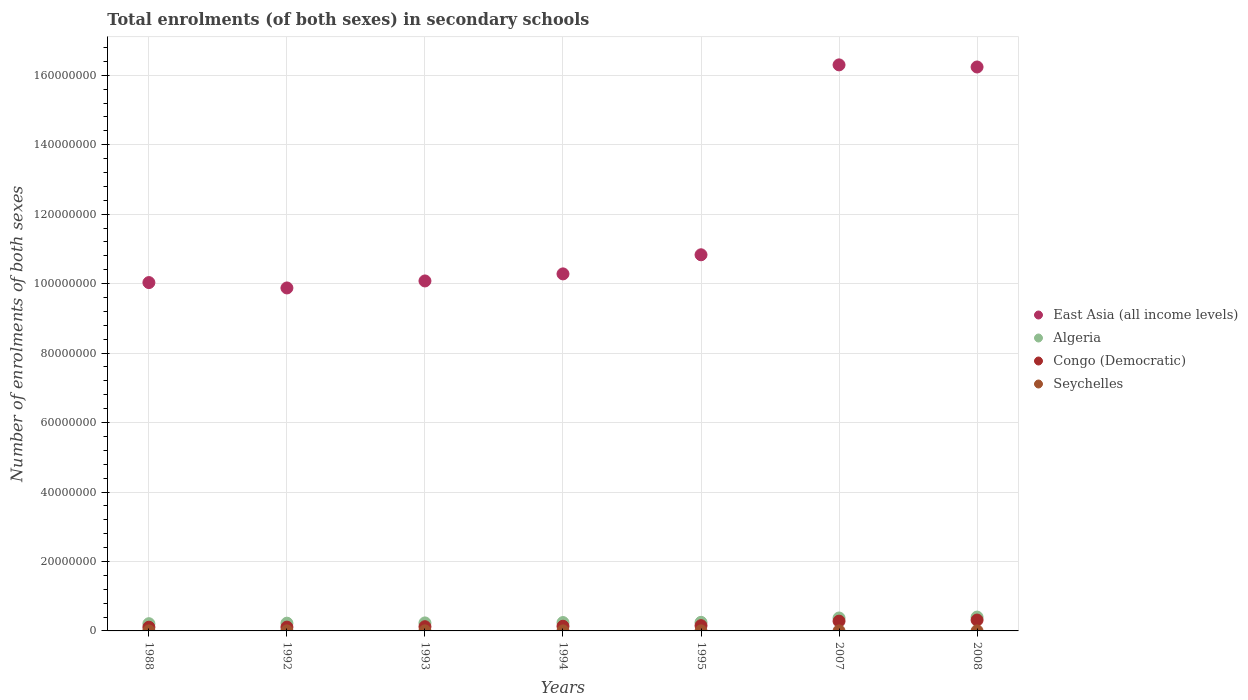How many different coloured dotlines are there?
Provide a succinct answer. 4. What is the number of enrolments in secondary schools in East Asia (all income levels) in 1995?
Your response must be concise. 1.08e+08. Across all years, what is the maximum number of enrolments in secondary schools in Congo (Democratic)?
Provide a succinct answer. 3.13e+06. Across all years, what is the minimum number of enrolments in secondary schools in Congo (Democratic)?
Your answer should be very brief. 1.07e+06. In which year was the number of enrolments in secondary schools in East Asia (all income levels) maximum?
Make the answer very short. 2007. What is the total number of enrolments in secondary schools in East Asia (all income levels) in the graph?
Your response must be concise. 8.36e+08. What is the difference between the number of enrolments in secondary schools in East Asia (all income levels) in 1994 and that in 2007?
Offer a very short reply. -6.02e+07. What is the difference between the number of enrolments in secondary schools in Algeria in 1993 and the number of enrolments in secondary schools in Congo (Democratic) in 2007?
Provide a short and direct response. -5.10e+05. What is the average number of enrolments in secondary schools in Seychelles per year?
Your answer should be compact. 8787.14. In the year 2008, what is the difference between the number of enrolments in secondary schools in Congo (Democratic) and number of enrolments in secondary schools in East Asia (all income levels)?
Provide a short and direct response. -1.59e+08. What is the ratio of the number of enrolments in secondary schools in Algeria in 1992 to that in 2007?
Your answer should be very brief. 0.6. Is the number of enrolments in secondary schools in East Asia (all income levels) in 1988 less than that in 2007?
Make the answer very short. Yes. What is the difference between the highest and the second highest number of enrolments in secondary schools in East Asia (all income levels)?
Give a very brief answer. 6.08e+05. What is the difference between the highest and the lowest number of enrolments in secondary schools in East Asia (all income levels)?
Your answer should be compact. 6.42e+07. In how many years, is the number of enrolments in secondary schools in Seychelles greater than the average number of enrolments in secondary schools in Seychelles taken over all years?
Provide a succinct answer. 5. Is the sum of the number of enrolments in secondary schools in Congo (Democratic) in 1994 and 2008 greater than the maximum number of enrolments in secondary schools in East Asia (all income levels) across all years?
Provide a short and direct response. No. Is it the case that in every year, the sum of the number of enrolments in secondary schools in East Asia (all income levels) and number of enrolments in secondary schools in Congo (Democratic)  is greater than the sum of number of enrolments in secondary schools in Seychelles and number of enrolments in secondary schools in Algeria?
Make the answer very short. No. How many years are there in the graph?
Offer a very short reply. 7. What is the difference between two consecutive major ticks on the Y-axis?
Offer a very short reply. 2.00e+07. Are the values on the major ticks of Y-axis written in scientific E-notation?
Provide a succinct answer. No. Does the graph contain any zero values?
Provide a short and direct response. No. How many legend labels are there?
Keep it short and to the point. 4. How are the legend labels stacked?
Give a very brief answer. Vertical. What is the title of the graph?
Offer a terse response. Total enrolments (of both sexes) in secondary schools. What is the label or title of the X-axis?
Ensure brevity in your answer.  Years. What is the label or title of the Y-axis?
Your response must be concise. Number of enrolments of both sexes. What is the Number of enrolments of both sexes of East Asia (all income levels) in 1988?
Keep it short and to the point. 1.00e+08. What is the Number of enrolments of both sexes of Algeria in 1988?
Your response must be concise. 2.08e+06. What is the Number of enrolments of both sexes in Congo (Democratic) in 1988?
Your response must be concise. 1.07e+06. What is the Number of enrolments of both sexes in Seychelles in 1988?
Your answer should be compact. 8868. What is the Number of enrolments of both sexes of East Asia (all income levels) in 1992?
Your answer should be compact. 9.88e+07. What is the Number of enrolments of both sexes in Algeria in 1992?
Provide a short and direct response. 2.23e+06. What is the Number of enrolments of both sexes in Congo (Democratic) in 1992?
Your answer should be compact. 1.10e+06. What is the Number of enrolments of both sexes in Seychelles in 1992?
Offer a very short reply. 9182. What is the Number of enrolments of both sexes in East Asia (all income levels) in 1993?
Make the answer very short. 1.01e+08. What is the Number of enrolments of both sexes of Algeria in 1993?
Offer a very short reply. 2.31e+06. What is the Number of enrolments of both sexes of Congo (Democratic) in 1993?
Provide a short and direct response. 1.22e+06. What is the Number of enrolments of both sexes in Seychelles in 1993?
Provide a succinct answer. 9111. What is the Number of enrolments of both sexes in East Asia (all income levels) in 1994?
Provide a succinct answer. 1.03e+08. What is the Number of enrolments of both sexes in Algeria in 1994?
Keep it short and to the point. 2.41e+06. What is the Number of enrolments of both sexes of Congo (Democratic) in 1994?
Give a very brief answer. 1.34e+06. What is the Number of enrolments of both sexes in Seychelles in 1994?
Offer a very short reply. 9280. What is the Number of enrolments of both sexes in East Asia (all income levels) in 1995?
Keep it short and to the point. 1.08e+08. What is the Number of enrolments of both sexes in Algeria in 1995?
Offer a very short reply. 2.47e+06. What is the Number of enrolments of both sexes of Congo (Democratic) in 1995?
Provide a succinct answer. 1.51e+06. What is the Number of enrolments of both sexes in Seychelles in 1995?
Your answer should be very brief. 8931. What is the Number of enrolments of both sexes of East Asia (all income levels) in 2007?
Your answer should be compact. 1.63e+08. What is the Number of enrolments of both sexes in Algeria in 2007?
Ensure brevity in your answer.  3.72e+06. What is the Number of enrolments of both sexes in Congo (Democratic) in 2007?
Your response must be concise. 2.82e+06. What is the Number of enrolments of both sexes in Seychelles in 2007?
Ensure brevity in your answer.  8227. What is the Number of enrolments of both sexes of East Asia (all income levels) in 2008?
Provide a short and direct response. 1.62e+08. What is the Number of enrolments of both sexes in Algeria in 2008?
Make the answer very short. 3.98e+06. What is the Number of enrolments of both sexes in Congo (Democratic) in 2008?
Give a very brief answer. 3.13e+06. What is the Number of enrolments of both sexes of Seychelles in 2008?
Give a very brief answer. 7911. Across all years, what is the maximum Number of enrolments of both sexes in East Asia (all income levels)?
Offer a terse response. 1.63e+08. Across all years, what is the maximum Number of enrolments of both sexes of Algeria?
Your answer should be very brief. 3.98e+06. Across all years, what is the maximum Number of enrolments of both sexes in Congo (Democratic)?
Your answer should be compact. 3.13e+06. Across all years, what is the maximum Number of enrolments of both sexes in Seychelles?
Offer a terse response. 9280. Across all years, what is the minimum Number of enrolments of both sexes in East Asia (all income levels)?
Offer a very short reply. 9.88e+07. Across all years, what is the minimum Number of enrolments of both sexes of Algeria?
Your response must be concise. 2.08e+06. Across all years, what is the minimum Number of enrolments of both sexes in Congo (Democratic)?
Give a very brief answer. 1.07e+06. Across all years, what is the minimum Number of enrolments of both sexes of Seychelles?
Provide a short and direct response. 7911. What is the total Number of enrolments of both sexes of East Asia (all income levels) in the graph?
Your answer should be very brief. 8.36e+08. What is the total Number of enrolments of both sexes in Algeria in the graph?
Your answer should be very brief. 1.92e+07. What is the total Number of enrolments of both sexes in Congo (Democratic) in the graph?
Make the answer very short. 1.22e+07. What is the total Number of enrolments of both sexes of Seychelles in the graph?
Offer a terse response. 6.15e+04. What is the difference between the Number of enrolments of both sexes of East Asia (all income levels) in 1988 and that in 1992?
Keep it short and to the point. 1.55e+06. What is the difference between the Number of enrolments of both sexes of Algeria in 1988 and that in 1992?
Provide a short and direct response. -1.50e+05. What is the difference between the Number of enrolments of both sexes in Congo (Democratic) in 1988 and that in 1992?
Provide a short and direct response. -3.07e+04. What is the difference between the Number of enrolments of both sexes of Seychelles in 1988 and that in 1992?
Offer a very short reply. -314. What is the difference between the Number of enrolments of both sexes of East Asia (all income levels) in 1988 and that in 1993?
Give a very brief answer. -4.70e+05. What is the difference between the Number of enrolments of both sexes in Algeria in 1988 and that in 1993?
Keep it short and to the point. -2.23e+05. What is the difference between the Number of enrolments of both sexes of Congo (Democratic) in 1988 and that in 1993?
Your response must be concise. -1.52e+05. What is the difference between the Number of enrolments of both sexes of Seychelles in 1988 and that in 1993?
Make the answer very short. -243. What is the difference between the Number of enrolments of both sexes of East Asia (all income levels) in 1988 and that in 1994?
Provide a succinct answer. -2.50e+06. What is the difference between the Number of enrolments of both sexes of Algeria in 1988 and that in 1994?
Provide a short and direct response. -3.29e+05. What is the difference between the Number of enrolments of both sexes of Congo (Democratic) in 1988 and that in 1994?
Provide a short and direct response. -2.75e+05. What is the difference between the Number of enrolments of both sexes in Seychelles in 1988 and that in 1994?
Offer a very short reply. -412. What is the difference between the Number of enrolments of both sexes in East Asia (all income levels) in 1988 and that in 1995?
Keep it short and to the point. -8.00e+06. What is the difference between the Number of enrolments of both sexes in Algeria in 1988 and that in 1995?
Ensure brevity in your answer.  -3.90e+05. What is the difference between the Number of enrolments of both sexes of Congo (Democratic) in 1988 and that in 1995?
Keep it short and to the point. -4.48e+05. What is the difference between the Number of enrolments of both sexes of Seychelles in 1988 and that in 1995?
Offer a terse response. -63. What is the difference between the Number of enrolments of both sexes in East Asia (all income levels) in 1988 and that in 2007?
Provide a succinct answer. -6.27e+07. What is the difference between the Number of enrolments of both sexes in Algeria in 1988 and that in 2007?
Provide a short and direct response. -1.64e+06. What is the difference between the Number of enrolments of both sexes in Congo (Democratic) in 1988 and that in 2007?
Make the answer very short. -1.75e+06. What is the difference between the Number of enrolments of both sexes of Seychelles in 1988 and that in 2007?
Your response must be concise. 641. What is the difference between the Number of enrolments of both sexes of East Asia (all income levels) in 1988 and that in 2008?
Your answer should be compact. -6.21e+07. What is the difference between the Number of enrolments of both sexes of Algeria in 1988 and that in 2008?
Make the answer very short. -1.90e+06. What is the difference between the Number of enrolments of both sexes in Congo (Democratic) in 1988 and that in 2008?
Your answer should be very brief. -2.06e+06. What is the difference between the Number of enrolments of both sexes of Seychelles in 1988 and that in 2008?
Provide a succinct answer. 957. What is the difference between the Number of enrolments of both sexes of East Asia (all income levels) in 1992 and that in 1993?
Your response must be concise. -2.02e+06. What is the difference between the Number of enrolments of both sexes in Algeria in 1992 and that in 1993?
Your answer should be compact. -7.24e+04. What is the difference between the Number of enrolments of both sexes of Congo (Democratic) in 1992 and that in 1993?
Your response must be concise. -1.22e+05. What is the difference between the Number of enrolments of both sexes of East Asia (all income levels) in 1992 and that in 1994?
Give a very brief answer. -4.05e+06. What is the difference between the Number of enrolments of both sexes of Algeria in 1992 and that in 1994?
Make the answer very short. -1.79e+05. What is the difference between the Number of enrolments of both sexes of Congo (Democratic) in 1992 and that in 1994?
Make the answer very short. -2.44e+05. What is the difference between the Number of enrolments of both sexes of Seychelles in 1992 and that in 1994?
Offer a terse response. -98. What is the difference between the Number of enrolments of both sexes in East Asia (all income levels) in 1992 and that in 1995?
Provide a succinct answer. -9.55e+06. What is the difference between the Number of enrolments of both sexes of Algeria in 1992 and that in 1995?
Make the answer very short. -2.40e+05. What is the difference between the Number of enrolments of both sexes of Congo (Democratic) in 1992 and that in 1995?
Give a very brief answer. -4.17e+05. What is the difference between the Number of enrolments of both sexes of Seychelles in 1992 and that in 1995?
Your answer should be compact. 251. What is the difference between the Number of enrolments of both sexes of East Asia (all income levels) in 1992 and that in 2007?
Your answer should be very brief. -6.42e+07. What is the difference between the Number of enrolments of both sexes in Algeria in 1992 and that in 2007?
Your response must be concise. -1.49e+06. What is the difference between the Number of enrolments of both sexes in Congo (Democratic) in 1992 and that in 2007?
Keep it short and to the point. -1.72e+06. What is the difference between the Number of enrolments of both sexes in Seychelles in 1992 and that in 2007?
Provide a short and direct response. 955. What is the difference between the Number of enrolments of both sexes of East Asia (all income levels) in 1992 and that in 2008?
Offer a very short reply. -6.36e+07. What is the difference between the Number of enrolments of both sexes in Algeria in 1992 and that in 2008?
Your response must be concise. -1.75e+06. What is the difference between the Number of enrolments of both sexes of Congo (Democratic) in 1992 and that in 2008?
Ensure brevity in your answer.  -2.03e+06. What is the difference between the Number of enrolments of both sexes of Seychelles in 1992 and that in 2008?
Keep it short and to the point. 1271. What is the difference between the Number of enrolments of both sexes in East Asia (all income levels) in 1993 and that in 1994?
Your response must be concise. -2.03e+06. What is the difference between the Number of enrolments of both sexes in Algeria in 1993 and that in 1994?
Offer a terse response. -1.07e+05. What is the difference between the Number of enrolments of both sexes of Congo (Democratic) in 1993 and that in 1994?
Your answer should be very brief. -1.23e+05. What is the difference between the Number of enrolments of both sexes of Seychelles in 1993 and that in 1994?
Make the answer very short. -169. What is the difference between the Number of enrolments of both sexes of East Asia (all income levels) in 1993 and that in 1995?
Your answer should be compact. -7.53e+06. What is the difference between the Number of enrolments of both sexes in Algeria in 1993 and that in 1995?
Your response must be concise. -1.67e+05. What is the difference between the Number of enrolments of both sexes in Congo (Democratic) in 1993 and that in 1995?
Your response must be concise. -2.96e+05. What is the difference between the Number of enrolments of both sexes in Seychelles in 1993 and that in 1995?
Your response must be concise. 180. What is the difference between the Number of enrolments of both sexes of East Asia (all income levels) in 1993 and that in 2007?
Offer a very short reply. -6.22e+07. What is the difference between the Number of enrolments of both sexes of Algeria in 1993 and that in 2007?
Make the answer very short. -1.42e+06. What is the difference between the Number of enrolments of both sexes in Congo (Democratic) in 1993 and that in 2007?
Keep it short and to the point. -1.60e+06. What is the difference between the Number of enrolments of both sexes in Seychelles in 1993 and that in 2007?
Your response must be concise. 884. What is the difference between the Number of enrolments of both sexes in East Asia (all income levels) in 1993 and that in 2008?
Your response must be concise. -6.16e+07. What is the difference between the Number of enrolments of both sexes of Algeria in 1993 and that in 2008?
Keep it short and to the point. -1.68e+06. What is the difference between the Number of enrolments of both sexes in Congo (Democratic) in 1993 and that in 2008?
Provide a succinct answer. -1.91e+06. What is the difference between the Number of enrolments of both sexes in Seychelles in 1993 and that in 2008?
Ensure brevity in your answer.  1200. What is the difference between the Number of enrolments of both sexes in East Asia (all income levels) in 1994 and that in 1995?
Provide a short and direct response. -5.50e+06. What is the difference between the Number of enrolments of both sexes of Algeria in 1994 and that in 1995?
Give a very brief answer. -6.05e+04. What is the difference between the Number of enrolments of both sexes of Congo (Democratic) in 1994 and that in 1995?
Your answer should be compact. -1.73e+05. What is the difference between the Number of enrolments of both sexes of Seychelles in 1994 and that in 1995?
Ensure brevity in your answer.  349. What is the difference between the Number of enrolments of both sexes of East Asia (all income levels) in 1994 and that in 2007?
Provide a short and direct response. -6.02e+07. What is the difference between the Number of enrolments of both sexes in Algeria in 1994 and that in 2007?
Make the answer very short. -1.31e+06. What is the difference between the Number of enrolments of both sexes of Congo (Democratic) in 1994 and that in 2007?
Your response must be concise. -1.47e+06. What is the difference between the Number of enrolments of both sexes in Seychelles in 1994 and that in 2007?
Your answer should be compact. 1053. What is the difference between the Number of enrolments of both sexes of East Asia (all income levels) in 1994 and that in 2008?
Your answer should be compact. -5.96e+07. What is the difference between the Number of enrolments of both sexes of Algeria in 1994 and that in 2008?
Your answer should be compact. -1.57e+06. What is the difference between the Number of enrolments of both sexes of Congo (Democratic) in 1994 and that in 2008?
Offer a very short reply. -1.79e+06. What is the difference between the Number of enrolments of both sexes of Seychelles in 1994 and that in 2008?
Your response must be concise. 1369. What is the difference between the Number of enrolments of both sexes in East Asia (all income levels) in 1995 and that in 2007?
Your answer should be compact. -5.47e+07. What is the difference between the Number of enrolments of both sexes of Algeria in 1995 and that in 2007?
Ensure brevity in your answer.  -1.25e+06. What is the difference between the Number of enrolments of both sexes in Congo (Democratic) in 1995 and that in 2007?
Ensure brevity in your answer.  -1.30e+06. What is the difference between the Number of enrolments of both sexes in Seychelles in 1995 and that in 2007?
Ensure brevity in your answer.  704. What is the difference between the Number of enrolments of both sexes in East Asia (all income levels) in 1995 and that in 2008?
Your answer should be compact. -5.41e+07. What is the difference between the Number of enrolments of both sexes in Algeria in 1995 and that in 2008?
Your answer should be very brief. -1.51e+06. What is the difference between the Number of enrolments of both sexes of Congo (Democratic) in 1995 and that in 2008?
Offer a very short reply. -1.62e+06. What is the difference between the Number of enrolments of both sexes in Seychelles in 1995 and that in 2008?
Your answer should be compact. 1020. What is the difference between the Number of enrolments of both sexes of East Asia (all income levels) in 2007 and that in 2008?
Offer a terse response. 6.08e+05. What is the difference between the Number of enrolments of both sexes in Algeria in 2007 and that in 2008?
Provide a short and direct response. -2.60e+05. What is the difference between the Number of enrolments of both sexes in Congo (Democratic) in 2007 and that in 2008?
Give a very brief answer. -3.14e+05. What is the difference between the Number of enrolments of both sexes in Seychelles in 2007 and that in 2008?
Offer a terse response. 316. What is the difference between the Number of enrolments of both sexes of East Asia (all income levels) in 1988 and the Number of enrolments of both sexes of Algeria in 1992?
Offer a terse response. 9.81e+07. What is the difference between the Number of enrolments of both sexes in East Asia (all income levels) in 1988 and the Number of enrolments of both sexes in Congo (Democratic) in 1992?
Give a very brief answer. 9.92e+07. What is the difference between the Number of enrolments of both sexes in East Asia (all income levels) in 1988 and the Number of enrolments of both sexes in Seychelles in 1992?
Ensure brevity in your answer.  1.00e+08. What is the difference between the Number of enrolments of both sexes in Algeria in 1988 and the Number of enrolments of both sexes in Congo (Democratic) in 1992?
Your answer should be compact. 9.86e+05. What is the difference between the Number of enrolments of both sexes of Algeria in 1988 and the Number of enrolments of both sexes of Seychelles in 1992?
Keep it short and to the point. 2.07e+06. What is the difference between the Number of enrolments of both sexes of Congo (Democratic) in 1988 and the Number of enrolments of both sexes of Seychelles in 1992?
Ensure brevity in your answer.  1.06e+06. What is the difference between the Number of enrolments of both sexes in East Asia (all income levels) in 1988 and the Number of enrolments of both sexes in Algeria in 1993?
Your answer should be very brief. 9.80e+07. What is the difference between the Number of enrolments of both sexes of East Asia (all income levels) in 1988 and the Number of enrolments of both sexes of Congo (Democratic) in 1993?
Your response must be concise. 9.91e+07. What is the difference between the Number of enrolments of both sexes in East Asia (all income levels) in 1988 and the Number of enrolments of both sexes in Seychelles in 1993?
Offer a very short reply. 1.00e+08. What is the difference between the Number of enrolments of both sexes in Algeria in 1988 and the Number of enrolments of both sexes in Congo (Democratic) in 1993?
Make the answer very short. 8.64e+05. What is the difference between the Number of enrolments of both sexes of Algeria in 1988 and the Number of enrolments of both sexes of Seychelles in 1993?
Keep it short and to the point. 2.07e+06. What is the difference between the Number of enrolments of both sexes of Congo (Democratic) in 1988 and the Number of enrolments of both sexes of Seychelles in 1993?
Your answer should be compact. 1.06e+06. What is the difference between the Number of enrolments of both sexes in East Asia (all income levels) in 1988 and the Number of enrolments of both sexes in Algeria in 1994?
Offer a terse response. 9.79e+07. What is the difference between the Number of enrolments of both sexes of East Asia (all income levels) in 1988 and the Number of enrolments of both sexes of Congo (Democratic) in 1994?
Provide a succinct answer. 9.90e+07. What is the difference between the Number of enrolments of both sexes of East Asia (all income levels) in 1988 and the Number of enrolments of both sexes of Seychelles in 1994?
Give a very brief answer. 1.00e+08. What is the difference between the Number of enrolments of both sexes of Algeria in 1988 and the Number of enrolments of both sexes of Congo (Democratic) in 1994?
Your response must be concise. 7.41e+05. What is the difference between the Number of enrolments of both sexes in Algeria in 1988 and the Number of enrolments of both sexes in Seychelles in 1994?
Offer a very short reply. 2.07e+06. What is the difference between the Number of enrolments of both sexes in Congo (Democratic) in 1988 and the Number of enrolments of both sexes in Seychelles in 1994?
Provide a short and direct response. 1.06e+06. What is the difference between the Number of enrolments of both sexes in East Asia (all income levels) in 1988 and the Number of enrolments of both sexes in Algeria in 1995?
Keep it short and to the point. 9.78e+07. What is the difference between the Number of enrolments of both sexes of East Asia (all income levels) in 1988 and the Number of enrolments of both sexes of Congo (Democratic) in 1995?
Your response must be concise. 9.88e+07. What is the difference between the Number of enrolments of both sexes in East Asia (all income levels) in 1988 and the Number of enrolments of both sexes in Seychelles in 1995?
Your response must be concise. 1.00e+08. What is the difference between the Number of enrolments of both sexes of Algeria in 1988 and the Number of enrolments of both sexes of Congo (Democratic) in 1995?
Keep it short and to the point. 5.68e+05. What is the difference between the Number of enrolments of both sexes in Algeria in 1988 and the Number of enrolments of both sexes in Seychelles in 1995?
Your response must be concise. 2.07e+06. What is the difference between the Number of enrolments of both sexes of Congo (Democratic) in 1988 and the Number of enrolments of both sexes of Seychelles in 1995?
Your answer should be compact. 1.06e+06. What is the difference between the Number of enrolments of both sexes of East Asia (all income levels) in 1988 and the Number of enrolments of both sexes of Algeria in 2007?
Offer a very short reply. 9.66e+07. What is the difference between the Number of enrolments of both sexes of East Asia (all income levels) in 1988 and the Number of enrolments of both sexes of Congo (Democratic) in 2007?
Provide a succinct answer. 9.75e+07. What is the difference between the Number of enrolments of both sexes in East Asia (all income levels) in 1988 and the Number of enrolments of both sexes in Seychelles in 2007?
Keep it short and to the point. 1.00e+08. What is the difference between the Number of enrolments of both sexes in Algeria in 1988 and the Number of enrolments of both sexes in Congo (Democratic) in 2007?
Provide a short and direct response. -7.33e+05. What is the difference between the Number of enrolments of both sexes in Algeria in 1988 and the Number of enrolments of both sexes in Seychelles in 2007?
Give a very brief answer. 2.07e+06. What is the difference between the Number of enrolments of both sexes of Congo (Democratic) in 1988 and the Number of enrolments of both sexes of Seychelles in 2007?
Ensure brevity in your answer.  1.06e+06. What is the difference between the Number of enrolments of both sexes in East Asia (all income levels) in 1988 and the Number of enrolments of both sexes in Algeria in 2008?
Offer a very short reply. 9.63e+07. What is the difference between the Number of enrolments of both sexes of East Asia (all income levels) in 1988 and the Number of enrolments of both sexes of Congo (Democratic) in 2008?
Ensure brevity in your answer.  9.72e+07. What is the difference between the Number of enrolments of both sexes in East Asia (all income levels) in 1988 and the Number of enrolments of both sexes in Seychelles in 2008?
Give a very brief answer. 1.00e+08. What is the difference between the Number of enrolments of both sexes in Algeria in 1988 and the Number of enrolments of both sexes in Congo (Democratic) in 2008?
Keep it short and to the point. -1.05e+06. What is the difference between the Number of enrolments of both sexes in Algeria in 1988 and the Number of enrolments of both sexes in Seychelles in 2008?
Give a very brief answer. 2.07e+06. What is the difference between the Number of enrolments of both sexes of Congo (Democratic) in 1988 and the Number of enrolments of both sexes of Seychelles in 2008?
Offer a very short reply. 1.06e+06. What is the difference between the Number of enrolments of both sexes in East Asia (all income levels) in 1992 and the Number of enrolments of both sexes in Algeria in 1993?
Make the answer very short. 9.65e+07. What is the difference between the Number of enrolments of both sexes in East Asia (all income levels) in 1992 and the Number of enrolments of both sexes in Congo (Democratic) in 1993?
Your response must be concise. 9.75e+07. What is the difference between the Number of enrolments of both sexes of East Asia (all income levels) in 1992 and the Number of enrolments of both sexes of Seychelles in 1993?
Make the answer very short. 9.87e+07. What is the difference between the Number of enrolments of both sexes in Algeria in 1992 and the Number of enrolments of both sexes in Congo (Democratic) in 1993?
Your answer should be compact. 1.01e+06. What is the difference between the Number of enrolments of both sexes of Algeria in 1992 and the Number of enrolments of both sexes of Seychelles in 1993?
Make the answer very short. 2.22e+06. What is the difference between the Number of enrolments of both sexes of Congo (Democratic) in 1992 and the Number of enrolments of both sexes of Seychelles in 1993?
Make the answer very short. 1.09e+06. What is the difference between the Number of enrolments of both sexes of East Asia (all income levels) in 1992 and the Number of enrolments of both sexes of Algeria in 1994?
Your answer should be compact. 9.63e+07. What is the difference between the Number of enrolments of both sexes of East Asia (all income levels) in 1992 and the Number of enrolments of both sexes of Congo (Democratic) in 1994?
Provide a short and direct response. 9.74e+07. What is the difference between the Number of enrolments of both sexes in East Asia (all income levels) in 1992 and the Number of enrolments of both sexes in Seychelles in 1994?
Provide a short and direct response. 9.87e+07. What is the difference between the Number of enrolments of both sexes of Algeria in 1992 and the Number of enrolments of both sexes of Congo (Democratic) in 1994?
Keep it short and to the point. 8.91e+05. What is the difference between the Number of enrolments of both sexes in Algeria in 1992 and the Number of enrolments of both sexes in Seychelles in 1994?
Offer a terse response. 2.22e+06. What is the difference between the Number of enrolments of both sexes of Congo (Democratic) in 1992 and the Number of enrolments of both sexes of Seychelles in 1994?
Your answer should be very brief. 1.09e+06. What is the difference between the Number of enrolments of both sexes of East Asia (all income levels) in 1992 and the Number of enrolments of both sexes of Algeria in 1995?
Make the answer very short. 9.63e+07. What is the difference between the Number of enrolments of both sexes in East Asia (all income levels) in 1992 and the Number of enrolments of both sexes in Congo (Democratic) in 1995?
Provide a succinct answer. 9.72e+07. What is the difference between the Number of enrolments of both sexes in East Asia (all income levels) in 1992 and the Number of enrolments of both sexes in Seychelles in 1995?
Offer a terse response. 9.87e+07. What is the difference between the Number of enrolments of both sexes in Algeria in 1992 and the Number of enrolments of both sexes in Congo (Democratic) in 1995?
Your answer should be very brief. 7.18e+05. What is the difference between the Number of enrolments of both sexes in Algeria in 1992 and the Number of enrolments of both sexes in Seychelles in 1995?
Your answer should be compact. 2.22e+06. What is the difference between the Number of enrolments of both sexes in Congo (Democratic) in 1992 and the Number of enrolments of both sexes in Seychelles in 1995?
Ensure brevity in your answer.  1.09e+06. What is the difference between the Number of enrolments of both sexes of East Asia (all income levels) in 1992 and the Number of enrolments of both sexes of Algeria in 2007?
Ensure brevity in your answer.  9.50e+07. What is the difference between the Number of enrolments of both sexes of East Asia (all income levels) in 1992 and the Number of enrolments of both sexes of Congo (Democratic) in 2007?
Keep it short and to the point. 9.59e+07. What is the difference between the Number of enrolments of both sexes in East Asia (all income levels) in 1992 and the Number of enrolments of both sexes in Seychelles in 2007?
Keep it short and to the point. 9.87e+07. What is the difference between the Number of enrolments of both sexes of Algeria in 1992 and the Number of enrolments of both sexes of Congo (Democratic) in 2007?
Ensure brevity in your answer.  -5.82e+05. What is the difference between the Number of enrolments of both sexes of Algeria in 1992 and the Number of enrolments of both sexes of Seychelles in 2007?
Offer a very short reply. 2.22e+06. What is the difference between the Number of enrolments of both sexes of Congo (Democratic) in 1992 and the Number of enrolments of both sexes of Seychelles in 2007?
Your answer should be very brief. 1.09e+06. What is the difference between the Number of enrolments of both sexes in East Asia (all income levels) in 1992 and the Number of enrolments of both sexes in Algeria in 2008?
Give a very brief answer. 9.48e+07. What is the difference between the Number of enrolments of both sexes of East Asia (all income levels) in 1992 and the Number of enrolments of both sexes of Congo (Democratic) in 2008?
Provide a short and direct response. 9.56e+07. What is the difference between the Number of enrolments of both sexes in East Asia (all income levels) in 1992 and the Number of enrolments of both sexes in Seychelles in 2008?
Offer a very short reply. 9.87e+07. What is the difference between the Number of enrolments of both sexes of Algeria in 1992 and the Number of enrolments of both sexes of Congo (Democratic) in 2008?
Provide a short and direct response. -8.97e+05. What is the difference between the Number of enrolments of both sexes of Algeria in 1992 and the Number of enrolments of both sexes of Seychelles in 2008?
Offer a terse response. 2.22e+06. What is the difference between the Number of enrolments of both sexes of Congo (Democratic) in 1992 and the Number of enrolments of both sexes of Seychelles in 2008?
Offer a terse response. 1.09e+06. What is the difference between the Number of enrolments of both sexes of East Asia (all income levels) in 1993 and the Number of enrolments of both sexes of Algeria in 1994?
Your response must be concise. 9.84e+07. What is the difference between the Number of enrolments of both sexes of East Asia (all income levels) in 1993 and the Number of enrolments of both sexes of Congo (Democratic) in 1994?
Your answer should be compact. 9.94e+07. What is the difference between the Number of enrolments of both sexes of East Asia (all income levels) in 1993 and the Number of enrolments of both sexes of Seychelles in 1994?
Provide a succinct answer. 1.01e+08. What is the difference between the Number of enrolments of both sexes of Algeria in 1993 and the Number of enrolments of both sexes of Congo (Democratic) in 1994?
Keep it short and to the point. 9.64e+05. What is the difference between the Number of enrolments of both sexes of Algeria in 1993 and the Number of enrolments of both sexes of Seychelles in 1994?
Give a very brief answer. 2.30e+06. What is the difference between the Number of enrolments of both sexes in Congo (Democratic) in 1993 and the Number of enrolments of both sexes in Seychelles in 1994?
Provide a short and direct response. 1.21e+06. What is the difference between the Number of enrolments of both sexes in East Asia (all income levels) in 1993 and the Number of enrolments of both sexes in Algeria in 1995?
Provide a succinct answer. 9.83e+07. What is the difference between the Number of enrolments of both sexes of East Asia (all income levels) in 1993 and the Number of enrolments of both sexes of Congo (Democratic) in 1995?
Your answer should be compact. 9.93e+07. What is the difference between the Number of enrolments of both sexes of East Asia (all income levels) in 1993 and the Number of enrolments of both sexes of Seychelles in 1995?
Your answer should be very brief. 1.01e+08. What is the difference between the Number of enrolments of both sexes of Algeria in 1993 and the Number of enrolments of both sexes of Congo (Democratic) in 1995?
Ensure brevity in your answer.  7.91e+05. What is the difference between the Number of enrolments of both sexes of Algeria in 1993 and the Number of enrolments of both sexes of Seychelles in 1995?
Make the answer very short. 2.30e+06. What is the difference between the Number of enrolments of both sexes of Congo (Democratic) in 1993 and the Number of enrolments of both sexes of Seychelles in 1995?
Provide a short and direct response. 1.21e+06. What is the difference between the Number of enrolments of both sexes in East Asia (all income levels) in 1993 and the Number of enrolments of both sexes in Algeria in 2007?
Keep it short and to the point. 9.70e+07. What is the difference between the Number of enrolments of both sexes of East Asia (all income levels) in 1993 and the Number of enrolments of both sexes of Congo (Democratic) in 2007?
Ensure brevity in your answer.  9.80e+07. What is the difference between the Number of enrolments of both sexes in East Asia (all income levels) in 1993 and the Number of enrolments of both sexes in Seychelles in 2007?
Offer a very short reply. 1.01e+08. What is the difference between the Number of enrolments of both sexes of Algeria in 1993 and the Number of enrolments of both sexes of Congo (Democratic) in 2007?
Your answer should be very brief. -5.10e+05. What is the difference between the Number of enrolments of both sexes in Algeria in 1993 and the Number of enrolments of both sexes in Seychelles in 2007?
Offer a very short reply. 2.30e+06. What is the difference between the Number of enrolments of both sexes in Congo (Democratic) in 1993 and the Number of enrolments of both sexes in Seychelles in 2007?
Your response must be concise. 1.21e+06. What is the difference between the Number of enrolments of both sexes of East Asia (all income levels) in 1993 and the Number of enrolments of both sexes of Algeria in 2008?
Your answer should be compact. 9.68e+07. What is the difference between the Number of enrolments of both sexes of East Asia (all income levels) in 1993 and the Number of enrolments of both sexes of Congo (Democratic) in 2008?
Ensure brevity in your answer.  9.76e+07. What is the difference between the Number of enrolments of both sexes in East Asia (all income levels) in 1993 and the Number of enrolments of both sexes in Seychelles in 2008?
Keep it short and to the point. 1.01e+08. What is the difference between the Number of enrolments of both sexes in Algeria in 1993 and the Number of enrolments of both sexes in Congo (Democratic) in 2008?
Your answer should be very brief. -8.24e+05. What is the difference between the Number of enrolments of both sexes of Algeria in 1993 and the Number of enrolments of both sexes of Seychelles in 2008?
Make the answer very short. 2.30e+06. What is the difference between the Number of enrolments of both sexes in Congo (Democratic) in 1993 and the Number of enrolments of both sexes in Seychelles in 2008?
Your response must be concise. 1.21e+06. What is the difference between the Number of enrolments of both sexes of East Asia (all income levels) in 1994 and the Number of enrolments of both sexes of Algeria in 1995?
Offer a terse response. 1.00e+08. What is the difference between the Number of enrolments of both sexes of East Asia (all income levels) in 1994 and the Number of enrolments of both sexes of Congo (Democratic) in 1995?
Make the answer very short. 1.01e+08. What is the difference between the Number of enrolments of both sexes in East Asia (all income levels) in 1994 and the Number of enrolments of both sexes in Seychelles in 1995?
Provide a succinct answer. 1.03e+08. What is the difference between the Number of enrolments of both sexes in Algeria in 1994 and the Number of enrolments of both sexes in Congo (Democratic) in 1995?
Offer a very short reply. 8.98e+05. What is the difference between the Number of enrolments of both sexes of Algeria in 1994 and the Number of enrolments of both sexes of Seychelles in 1995?
Your answer should be compact. 2.40e+06. What is the difference between the Number of enrolments of both sexes in Congo (Democratic) in 1994 and the Number of enrolments of both sexes in Seychelles in 1995?
Make the answer very short. 1.33e+06. What is the difference between the Number of enrolments of both sexes of East Asia (all income levels) in 1994 and the Number of enrolments of both sexes of Algeria in 2007?
Offer a very short reply. 9.91e+07. What is the difference between the Number of enrolments of both sexes in East Asia (all income levels) in 1994 and the Number of enrolments of both sexes in Congo (Democratic) in 2007?
Make the answer very short. 1.00e+08. What is the difference between the Number of enrolments of both sexes in East Asia (all income levels) in 1994 and the Number of enrolments of both sexes in Seychelles in 2007?
Provide a short and direct response. 1.03e+08. What is the difference between the Number of enrolments of both sexes of Algeria in 1994 and the Number of enrolments of both sexes of Congo (Democratic) in 2007?
Your response must be concise. -4.03e+05. What is the difference between the Number of enrolments of both sexes in Algeria in 1994 and the Number of enrolments of both sexes in Seychelles in 2007?
Give a very brief answer. 2.40e+06. What is the difference between the Number of enrolments of both sexes in Congo (Democratic) in 1994 and the Number of enrolments of both sexes in Seychelles in 2007?
Offer a terse response. 1.33e+06. What is the difference between the Number of enrolments of both sexes of East Asia (all income levels) in 1994 and the Number of enrolments of both sexes of Algeria in 2008?
Your response must be concise. 9.88e+07. What is the difference between the Number of enrolments of both sexes in East Asia (all income levels) in 1994 and the Number of enrolments of both sexes in Congo (Democratic) in 2008?
Provide a short and direct response. 9.97e+07. What is the difference between the Number of enrolments of both sexes in East Asia (all income levels) in 1994 and the Number of enrolments of both sexes in Seychelles in 2008?
Your answer should be compact. 1.03e+08. What is the difference between the Number of enrolments of both sexes of Algeria in 1994 and the Number of enrolments of both sexes of Congo (Democratic) in 2008?
Your answer should be compact. -7.17e+05. What is the difference between the Number of enrolments of both sexes in Algeria in 1994 and the Number of enrolments of both sexes in Seychelles in 2008?
Your response must be concise. 2.40e+06. What is the difference between the Number of enrolments of both sexes of Congo (Democratic) in 1994 and the Number of enrolments of both sexes of Seychelles in 2008?
Ensure brevity in your answer.  1.33e+06. What is the difference between the Number of enrolments of both sexes of East Asia (all income levels) in 1995 and the Number of enrolments of both sexes of Algeria in 2007?
Make the answer very short. 1.05e+08. What is the difference between the Number of enrolments of both sexes in East Asia (all income levels) in 1995 and the Number of enrolments of both sexes in Congo (Democratic) in 2007?
Give a very brief answer. 1.05e+08. What is the difference between the Number of enrolments of both sexes of East Asia (all income levels) in 1995 and the Number of enrolments of both sexes of Seychelles in 2007?
Provide a succinct answer. 1.08e+08. What is the difference between the Number of enrolments of both sexes in Algeria in 1995 and the Number of enrolments of both sexes in Congo (Democratic) in 2007?
Make the answer very short. -3.43e+05. What is the difference between the Number of enrolments of both sexes in Algeria in 1995 and the Number of enrolments of both sexes in Seychelles in 2007?
Give a very brief answer. 2.46e+06. What is the difference between the Number of enrolments of both sexes of Congo (Democratic) in 1995 and the Number of enrolments of both sexes of Seychelles in 2007?
Your answer should be compact. 1.51e+06. What is the difference between the Number of enrolments of both sexes of East Asia (all income levels) in 1995 and the Number of enrolments of both sexes of Algeria in 2008?
Your response must be concise. 1.04e+08. What is the difference between the Number of enrolments of both sexes in East Asia (all income levels) in 1995 and the Number of enrolments of both sexes in Congo (Democratic) in 2008?
Offer a terse response. 1.05e+08. What is the difference between the Number of enrolments of both sexes of East Asia (all income levels) in 1995 and the Number of enrolments of both sexes of Seychelles in 2008?
Offer a terse response. 1.08e+08. What is the difference between the Number of enrolments of both sexes of Algeria in 1995 and the Number of enrolments of both sexes of Congo (Democratic) in 2008?
Make the answer very short. -6.57e+05. What is the difference between the Number of enrolments of both sexes of Algeria in 1995 and the Number of enrolments of both sexes of Seychelles in 2008?
Provide a succinct answer. 2.46e+06. What is the difference between the Number of enrolments of both sexes in Congo (Democratic) in 1995 and the Number of enrolments of both sexes in Seychelles in 2008?
Ensure brevity in your answer.  1.51e+06. What is the difference between the Number of enrolments of both sexes in East Asia (all income levels) in 2007 and the Number of enrolments of both sexes in Algeria in 2008?
Keep it short and to the point. 1.59e+08. What is the difference between the Number of enrolments of both sexes in East Asia (all income levels) in 2007 and the Number of enrolments of both sexes in Congo (Democratic) in 2008?
Your answer should be compact. 1.60e+08. What is the difference between the Number of enrolments of both sexes of East Asia (all income levels) in 2007 and the Number of enrolments of both sexes of Seychelles in 2008?
Give a very brief answer. 1.63e+08. What is the difference between the Number of enrolments of both sexes of Algeria in 2007 and the Number of enrolments of both sexes of Congo (Democratic) in 2008?
Make the answer very short. 5.95e+05. What is the difference between the Number of enrolments of both sexes in Algeria in 2007 and the Number of enrolments of both sexes in Seychelles in 2008?
Give a very brief answer. 3.72e+06. What is the difference between the Number of enrolments of both sexes of Congo (Democratic) in 2007 and the Number of enrolments of both sexes of Seychelles in 2008?
Offer a very short reply. 2.81e+06. What is the average Number of enrolments of both sexes of East Asia (all income levels) per year?
Keep it short and to the point. 1.19e+08. What is the average Number of enrolments of both sexes of Algeria per year?
Offer a very short reply. 2.74e+06. What is the average Number of enrolments of both sexes in Congo (Democratic) per year?
Give a very brief answer. 1.74e+06. What is the average Number of enrolments of both sexes in Seychelles per year?
Offer a terse response. 8787.14. In the year 1988, what is the difference between the Number of enrolments of both sexes of East Asia (all income levels) and Number of enrolments of both sexes of Algeria?
Offer a terse response. 9.82e+07. In the year 1988, what is the difference between the Number of enrolments of both sexes of East Asia (all income levels) and Number of enrolments of both sexes of Congo (Democratic)?
Give a very brief answer. 9.92e+07. In the year 1988, what is the difference between the Number of enrolments of both sexes in East Asia (all income levels) and Number of enrolments of both sexes in Seychelles?
Your answer should be compact. 1.00e+08. In the year 1988, what is the difference between the Number of enrolments of both sexes in Algeria and Number of enrolments of both sexes in Congo (Democratic)?
Offer a terse response. 1.02e+06. In the year 1988, what is the difference between the Number of enrolments of both sexes of Algeria and Number of enrolments of both sexes of Seychelles?
Give a very brief answer. 2.07e+06. In the year 1988, what is the difference between the Number of enrolments of both sexes in Congo (Democratic) and Number of enrolments of both sexes in Seychelles?
Your answer should be compact. 1.06e+06. In the year 1992, what is the difference between the Number of enrolments of both sexes of East Asia (all income levels) and Number of enrolments of both sexes of Algeria?
Offer a very short reply. 9.65e+07. In the year 1992, what is the difference between the Number of enrolments of both sexes in East Asia (all income levels) and Number of enrolments of both sexes in Congo (Democratic)?
Give a very brief answer. 9.77e+07. In the year 1992, what is the difference between the Number of enrolments of both sexes of East Asia (all income levels) and Number of enrolments of both sexes of Seychelles?
Provide a succinct answer. 9.87e+07. In the year 1992, what is the difference between the Number of enrolments of both sexes in Algeria and Number of enrolments of both sexes in Congo (Democratic)?
Ensure brevity in your answer.  1.14e+06. In the year 1992, what is the difference between the Number of enrolments of both sexes in Algeria and Number of enrolments of both sexes in Seychelles?
Provide a succinct answer. 2.22e+06. In the year 1992, what is the difference between the Number of enrolments of both sexes in Congo (Democratic) and Number of enrolments of both sexes in Seychelles?
Your answer should be very brief. 1.09e+06. In the year 1993, what is the difference between the Number of enrolments of both sexes in East Asia (all income levels) and Number of enrolments of both sexes in Algeria?
Provide a short and direct response. 9.85e+07. In the year 1993, what is the difference between the Number of enrolments of both sexes in East Asia (all income levels) and Number of enrolments of both sexes in Congo (Democratic)?
Keep it short and to the point. 9.96e+07. In the year 1993, what is the difference between the Number of enrolments of both sexes in East Asia (all income levels) and Number of enrolments of both sexes in Seychelles?
Make the answer very short. 1.01e+08. In the year 1993, what is the difference between the Number of enrolments of both sexes of Algeria and Number of enrolments of both sexes of Congo (Democratic)?
Your answer should be very brief. 1.09e+06. In the year 1993, what is the difference between the Number of enrolments of both sexes in Algeria and Number of enrolments of both sexes in Seychelles?
Offer a very short reply. 2.30e+06. In the year 1993, what is the difference between the Number of enrolments of both sexes in Congo (Democratic) and Number of enrolments of both sexes in Seychelles?
Offer a terse response. 1.21e+06. In the year 1994, what is the difference between the Number of enrolments of both sexes of East Asia (all income levels) and Number of enrolments of both sexes of Algeria?
Offer a terse response. 1.00e+08. In the year 1994, what is the difference between the Number of enrolments of both sexes of East Asia (all income levels) and Number of enrolments of both sexes of Congo (Democratic)?
Give a very brief answer. 1.01e+08. In the year 1994, what is the difference between the Number of enrolments of both sexes of East Asia (all income levels) and Number of enrolments of both sexes of Seychelles?
Ensure brevity in your answer.  1.03e+08. In the year 1994, what is the difference between the Number of enrolments of both sexes in Algeria and Number of enrolments of both sexes in Congo (Democratic)?
Keep it short and to the point. 1.07e+06. In the year 1994, what is the difference between the Number of enrolments of both sexes in Algeria and Number of enrolments of both sexes in Seychelles?
Offer a very short reply. 2.40e+06. In the year 1994, what is the difference between the Number of enrolments of both sexes in Congo (Democratic) and Number of enrolments of both sexes in Seychelles?
Your response must be concise. 1.33e+06. In the year 1995, what is the difference between the Number of enrolments of both sexes in East Asia (all income levels) and Number of enrolments of both sexes in Algeria?
Offer a very short reply. 1.06e+08. In the year 1995, what is the difference between the Number of enrolments of both sexes of East Asia (all income levels) and Number of enrolments of both sexes of Congo (Democratic)?
Give a very brief answer. 1.07e+08. In the year 1995, what is the difference between the Number of enrolments of both sexes in East Asia (all income levels) and Number of enrolments of both sexes in Seychelles?
Give a very brief answer. 1.08e+08. In the year 1995, what is the difference between the Number of enrolments of both sexes in Algeria and Number of enrolments of both sexes in Congo (Democratic)?
Offer a terse response. 9.58e+05. In the year 1995, what is the difference between the Number of enrolments of both sexes in Algeria and Number of enrolments of both sexes in Seychelles?
Your response must be concise. 2.46e+06. In the year 1995, what is the difference between the Number of enrolments of both sexes of Congo (Democratic) and Number of enrolments of both sexes of Seychelles?
Ensure brevity in your answer.  1.51e+06. In the year 2007, what is the difference between the Number of enrolments of both sexes of East Asia (all income levels) and Number of enrolments of both sexes of Algeria?
Your response must be concise. 1.59e+08. In the year 2007, what is the difference between the Number of enrolments of both sexes in East Asia (all income levels) and Number of enrolments of both sexes in Congo (Democratic)?
Your response must be concise. 1.60e+08. In the year 2007, what is the difference between the Number of enrolments of both sexes of East Asia (all income levels) and Number of enrolments of both sexes of Seychelles?
Offer a terse response. 1.63e+08. In the year 2007, what is the difference between the Number of enrolments of both sexes of Algeria and Number of enrolments of both sexes of Congo (Democratic)?
Offer a terse response. 9.09e+05. In the year 2007, what is the difference between the Number of enrolments of both sexes in Algeria and Number of enrolments of both sexes in Seychelles?
Make the answer very short. 3.72e+06. In the year 2007, what is the difference between the Number of enrolments of both sexes of Congo (Democratic) and Number of enrolments of both sexes of Seychelles?
Your answer should be very brief. 2.81e+06. In the year 2008, what is the difference between the Number of enrolments of both sexes of East Asia (all income levels) and Number of enrolments of both sexes of Algeria?
Offer a very short reply. 1.58e+08. In the year 2008, what is the difference between the Number of enrolments of both sexes of East Asia (all income levels) and Number of enrolments of both sexes of Congo (Democratic)?
Ensure brevity in your answer.  1.59e+08. In the year 2008, what is the difference between the Number of enrolments of both sexes in East Asia (all income levels) and Number of enrolments of both sexes in Seychelles?
Keep it short and to the point. 1.62e+08. In the year 2008, what is the difference between the Number of enrolments of both sexes in Algeria and Number of enrolments of both sexes in Congo (Democratic)?
Offer a terse response. 8.55e+05. In the year 2008, what is the difference between the Number of enrolments of both sexes in Algeria and Number of enrolments of both sexes in Seychelles?
Your response must be concise. 3.98e+06. In the year 2008, what is the difference between the Number of enrolments of both sexes in Congo (Democratic) and Number of enrolments of both sexes in Seychelles?
Keep it short and to the point. 3.12e+06. What is the ratio of the Number of enrolments of both sexes in East Asia (all income levels) in 1988 to that in 1992?
Your answer should be very brief. 1.02. What is the ratio of the Number of enrolments of both sexes in Algeria in 1988 to that in 1992?
Keep it short and to the point. 0.93. What is the ratio of the Number of enrolments of both sexes in Seychelles in 1988 to that in 1992?
Offer a very short reply. 0.97. What is the ratio of the Number of enrolments of both sexes of East Asia (all income levels) in 1988 to that in 1993?
Ensure brevity in your answer.  1. What is the ratio of the Number of enrolments of both sexes in Algeria in 1988 to that in 1993?
Ensure brevity in your answer.  0.9. What is the ratio of the Number of enrolments of both sexes in Congo (Democratic) in 1988 to that in 1993?
Provide a succinct answer. 0.87. What is the ratio of the Number of enrolments of both sexes in Seychelles in 1988 to that in 1993?
Make the answer very short. 0.97. What is the ratio of the Number of enrolments of both sexes in East Asia (all income levels) in 1988 to that in 1994?
Make the answer very short. 0.98. What is the ratio of the Number of enrolments of both sexes of Algeria in 1988 to that in 1994?
Your answer should be compact. 0.86. What is the ratio of the Number of enrolments of both sexes in Congo (Democratic) in 1988 to that in 1994?
Offer a terse response. 0.79. What is the ratio of the Number of enrolments of both sexes in Seychelles in 1988 to that in 1994?
Your answer should be compact. 0.96. What is the ratio of the Number of enrolments of both sexes in East Asia (all income levels) in 1988 to that in 1995?
Provide a succinct answer. 0.93. What is the ratio of the Number of enrolments of both sexes of Algeria in 1988 to that in 1995?
Keep it short and to the point. 0.84. What is the ratio of the Number of enrolments of both sexes in Congo (Democratic) in 1988 to that in 1995?
Your response must be concise. 0.7. What is the ratio of the Number of enrolments of both sexes of Seychelles in 1988 to that in 1995?
Make the answer very short. 0.99. What is the ratio of the Number of enrolments of both sexes of East Asia (all income levels) in 1988 to that in 2007?
Ensure brevity in your answer.  0.62. What is the ratio of the Number of enrolments of both sexes in Algeria in 1988 to that in 2007?
Provide a succinct answer. 0.56. What is the ratio of the Number of enrolments of both sexes of Congo (Democratic) in 1988 to that in 2007?
Provide a short and direct response. 0.38. What is the ratio of the Number of enrolments of both sexes of Seychelles in 1988 to that in 2007?
Keep it short and to the point. 1.08. What is the ratio of the Number of enrolments of both sexes of East Asia (all income levels) in 1988 to that in 2008?
Your response must be concise. 0.62. What is the ratio of the Number of enrolments of both sexes in Algeria in 1988 to that in 2008?
Make the answer very short. 0.52. What is the ratio of the Number of enrolments of both sexes of Congo (Democratic) in 1988 to that in 2008?
Make the answer very short. 0.34. What is the ratio of the Number of enrolments of both sexes in Seychelles in 1988 to that in 2008?
Make the answer very short. 1.12. What is the ratio of the Number of enrolments of both sexes of Algeria in 1992 to that in 1993?
Provide a short and direct response. 0.97. What is the ratio of the Number of enrolments of both sexes of Congo (Democratic) in 1992 to that in 1993?
Your answer should be very brief. 0.9. What is the ratio of the Number of enrolments of both sexes in Seychelles in 1992 to that in 1993?
Your answer should be compact. 1.01. What is the ratio of the Number of enrolments of both sexes of East Asia (all income levels) in 1992 to that in 1994?
Offer a terse response. 0.96. What is the ratio of the Number of enrolments of both sexes of Algeria in 1992 to that in 1994?
Offer a very short reply. 0.93. What is the ratio of the Number of enrolments of both sexes in Congo (Democratic) in 1992 to that in 1994?
Offer a terse response. 0.82. What is the ratio of the Number of enrolments of both sexes in East Asia (all income levels) in 1992 to that in 1995?
Your answer should be compact. 0.91. What is the ratio of the Number of enrolments of both sexes in Algeria in 1992 to that in 1995?
Keep it short and to the point. 0.9. What is the ratio of the Number of enrolments of both sexes of Congo (Democratic) in 1992 to that in 1995?
Your answer should be compact. 0.72. What is the ratio of the Number of enrolments of both sexes in Seychelles in 1992 to that in 1995?
Provide a succinct answer. 1.03. What is the ratio of the Number of enrolments of both sexes in East Asia (all income levels) in 1992 to that in 2007?
Your answer should be very brief. 0.61. What is the ratio of the Number of enrolments of both sexes in Algeria in 1992 to that in 2007?
Offer a terse response. 0.6. What is the ratio of the Number of enrolments of both sexes in Congo (Democratic) in 1992 to that in 2007?
Provide a short and direct response. 0.39. What is the ratio of the Number of enrolments of both sexes of Seychelles in 1992 to that in 2007?
Your response must be concise. 1.12. What is the ratio of the Number of enrolments of both sexes in East Asia (all income levels) in 1992 to that in 2008?
Your answer should be very brief. 0.61. What is the ratio of the Number of enrolments of both sexes in Algeria in 1992 to that in 2008?
Your answer should be compact. 0.56. What is the ratio of the Number of enrolments of both sexes in Congo (Democratic) in 1992 to that in 2008?
Provide a succinct answer. 0.35. What is the ratio of the Number of enrolments of both sexes in Seychelles in 1992 to that in 2008?
Ensure brevity in your answer.  1.16. What is the ratio of the Number of enrolments of both sexes in East Asia (all income levels) in 1993 to that in 1994?
Provide a short and direct response. 0.98. What is the ratio of the Number of enrolments of both sexes in Algeria in 1993 to that in 1994?
Provide a succinct answer. 0.96. What is the ratio of the Number of enrolments of both sexes of Congo (Democratic) in 1993 to that in 1994?
Provide a short and direct response. 0.91. What is the ratio of the Number of enrolments of both sexes in Seychelles in 1993 to that in 1994?
Offer a very short reply. 0.98. What is the ratio of the Number of enrolments of both sexes in East Asia (all income levels) in 1993 to that in 1995?
Ensure brevity in your answer.  0.93. What is the ratio of the Number of enrolments of both sexes of Algeria in 1993 to that in 1995?
Ensure brevity in your answer.  0.93. What is the ratio of the Number of enrolments of both sexes of Congo (Democratic) in 1993 to that in 1995?
Your response must be concise. 0.8. What is the ratio of the Number of enrolments of both sexes of Seychelles in 1993 to that in 1995?
Provide a short and direct response. 1.02. What is the ratio of the Number of enrolments of both sexes in East Asia (all income levels) in 1993 to that in 2007?
Keep it short and to the point. 0.62. What is the ratio of the Number of enrolments of both sexes in Algeria in 1993 to that in 2007?
Provide a succinct answer. 0.62. What is the ratio of the Number of enrolments of both sexes in Congo (Democratic) in 1993 to that in 2007?
Offer a terse response. 0.43. What is the ratio of the Number of enrolments of both sexes of Seychelles in 1993 to that in 2007?
Your answer should be very brief. 1.11. What is the ratio of the Number of enrolments of both sexes of East Asia (all income levels) in 1993 to that in 2008?
Offer a terse response. 0.62. What is the ratio of the Number of enrolments of both sexes in Algeria in 1993 to that in 2008?
Keep it short and to the point. 0.58. What is the ratio of the Number of enrolments of both sexes of Congo (Democratic) in 1993 to that in 2008?
Your answer should be very brief. 0.39. What is the ratio of the Number of enrolments of both sexes of Seychelles in 1993 to that in 2008?
Offer a very short reply. 1.15. What is the ratio of the Number of enrolments of both sexes of East Asia (all income levels) in 1994 to that in 1995?
Provide a succinct answer. 0.95. What is the ratio of the Number of enrolments of both sexes of Algeria in 1994 to that in 1995?
Provide a short and direct response. 0.98. What is the ratio of the Number of enrolments of both sexes of Congo (Democratic) in 1994 to that in 1995?
Your answer should be compact. 0.89. What is the ratio of the Number of enrolments of both sexes in Seychelles in 1994 to that in 1995?
Make the answer very short. 1.04. What is the ratio of the Number of enrolments of both sexes in East Asia (all income levels) in 1994 to that in 2007?
Your response must be concise. 0.63. What is the ratio of the Number of enrolments of both sexes in Algeria in 1994 to that in 2007?
Provide a succinct answer. 0.65. What is the ratio of the Number of enrolments of both sexes of Congo (Democratic) in 1994 to that in 2007?
Your response must be concise. 0.48. What is the ratio of the Number of enrolments of both sexes of Seychelles in 1994 to that in 2007?
Your answer should be compact. 1.13. What is the ratio of the Number of enrolments of both sexes of East Asia (all income levels) in 1994 to that in 2008?
Keep it short and to the point. 0.63. What is the ratio of the Number of enrolments of both sexes of Algeria in 1994 to that in 2008?
Offer a very short reply. 0.61. What is the ratio of the Number of enrolments of both sexes of Congo (Democratic) in 1994 to that in 2008?
Your answer should be compact. 0.43. What is the ratio of the Number of enrolments of both sexes of Seychelles in 1994 to that in 2008?
Provide a short and direct response. 1.17. What is the ratio of the Number of enrolments of both sexes in East Asia (all income levels) in 1995 to that in 2007?
Give a very brief answer. 0.66. What is the ratio of the Number of enrolments of both sexes of Algeria in 1995 to that in 2007?
Your response must be concise. 0.66. What is the ratio of the Number of enrolments of both sexes in Congo (Democratic) in 1995 to that in 2007?
Offer a terse response. 0.54. What is the ratio of the Number of enrolments of both sexes of Seychelles in 1995 to that in 2007?
Your answer should be very brief. 1.09. What is the ratio of the Number of enrolments of both sexes in East Asia (all income levels) in 1995 to that in 2008?
Ensure brevity in your answer.  0.67. What is the ratio of the Number of enrolments of both sexes in Algeria in 1995 to that in 2008?
Ensure brevity in your answer.  0.62. What is the ratio of the Number of enrolments of both sexes of Congo (Democratic) in 1995 to that in 2008?
Offer a terse response. 0.48. What is the ratio of the Number of enrolments of both sexes in Seychelles in 1995 to that in 2008?
Keep it short and to the point. 1.13. What is the ratio of the Number of enrolments of both sexes of Algeria in 2007 to that in 2008?
Give a very brief answer. 0.93. What is the ratio of the Number of enrolments of both sexes of Congo (Democratic) in 2007 to that in 2008?
Your answer should be very brief. 0.9. What is the ratio of the Number of enrolments of both sexes in Seychelles in 2007 to that in 2008?
Provide a short and direct response. 1.04. What is the difference between the highest and the second highest Number of enrolments of both sexes of East Asia (all income levels)?
Provide a succinct answer. 6.08e+05. What is the difference between the highest and the second highest Number of enrolments of both sexes of Algeria?
Your answer should be very brief. 2.60e+05. What is the difference between the highest and the second highest Number of enrolments of both sexes of Congo (Democratic)?
Your answer should be compact. 3.14e+05. What is the difference between the highest and the lowest Number of enrolments of both sexes in East Asia (all income levels)?
Provide a succinct answer. 6.42e+07. What is the difference between the highest and the lowest Number of enrolments of both sexes of Algeria?
Give a very brief answer. 1.90e+06. What is the difference between the highest and the lowest Number of enrolments of both sexes of Congo (Democratic)?
Your response must be concise. 2.06e+06. What is the difference between the highest and the lowest Number of enrolments of both sexes in Seychelles?
Provide a short and direct response. 1369. 